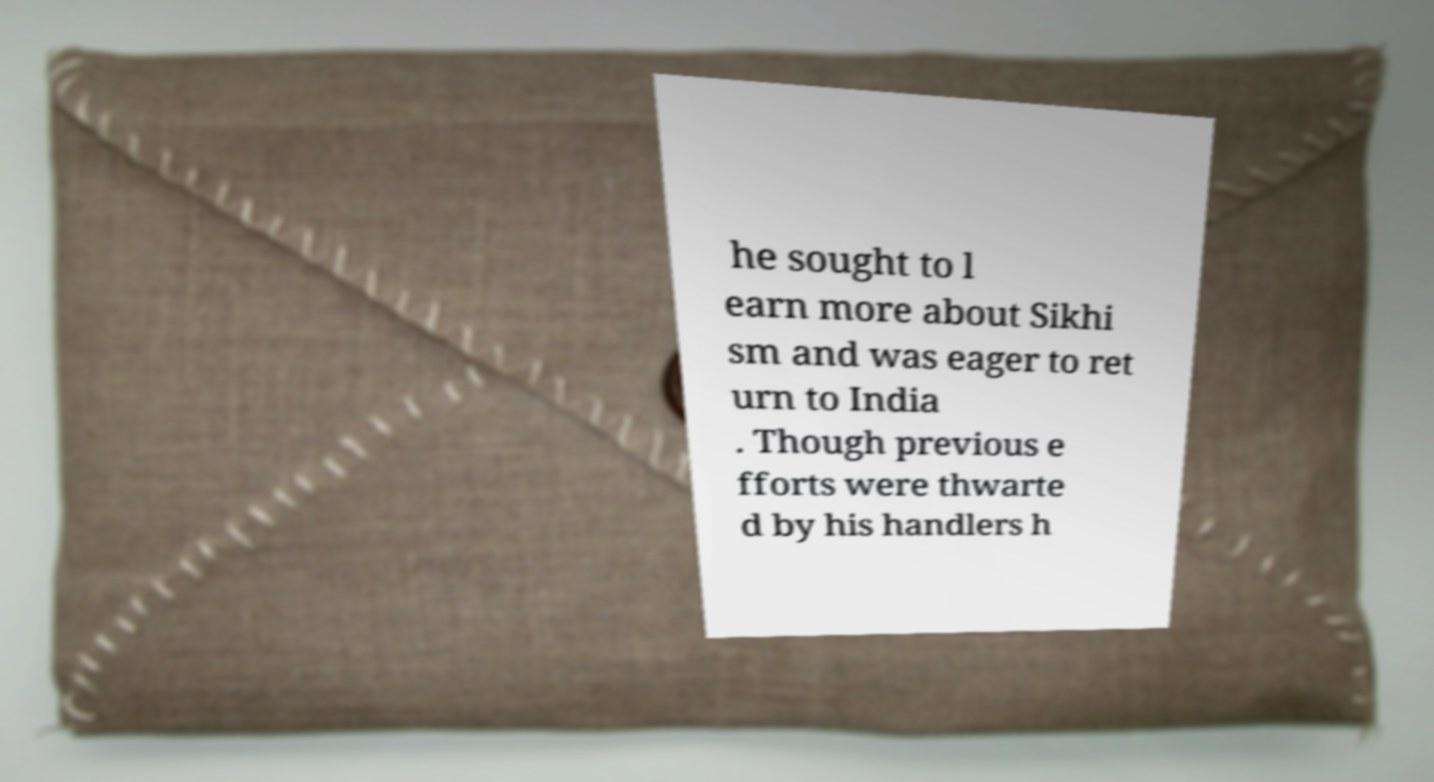I need the written content from this picture converted into text. Can you do that? he sought to l earn more about Sikhi sm and was eager to ret urn to India . Though previous e fforts were thwarte d by his handlers h 